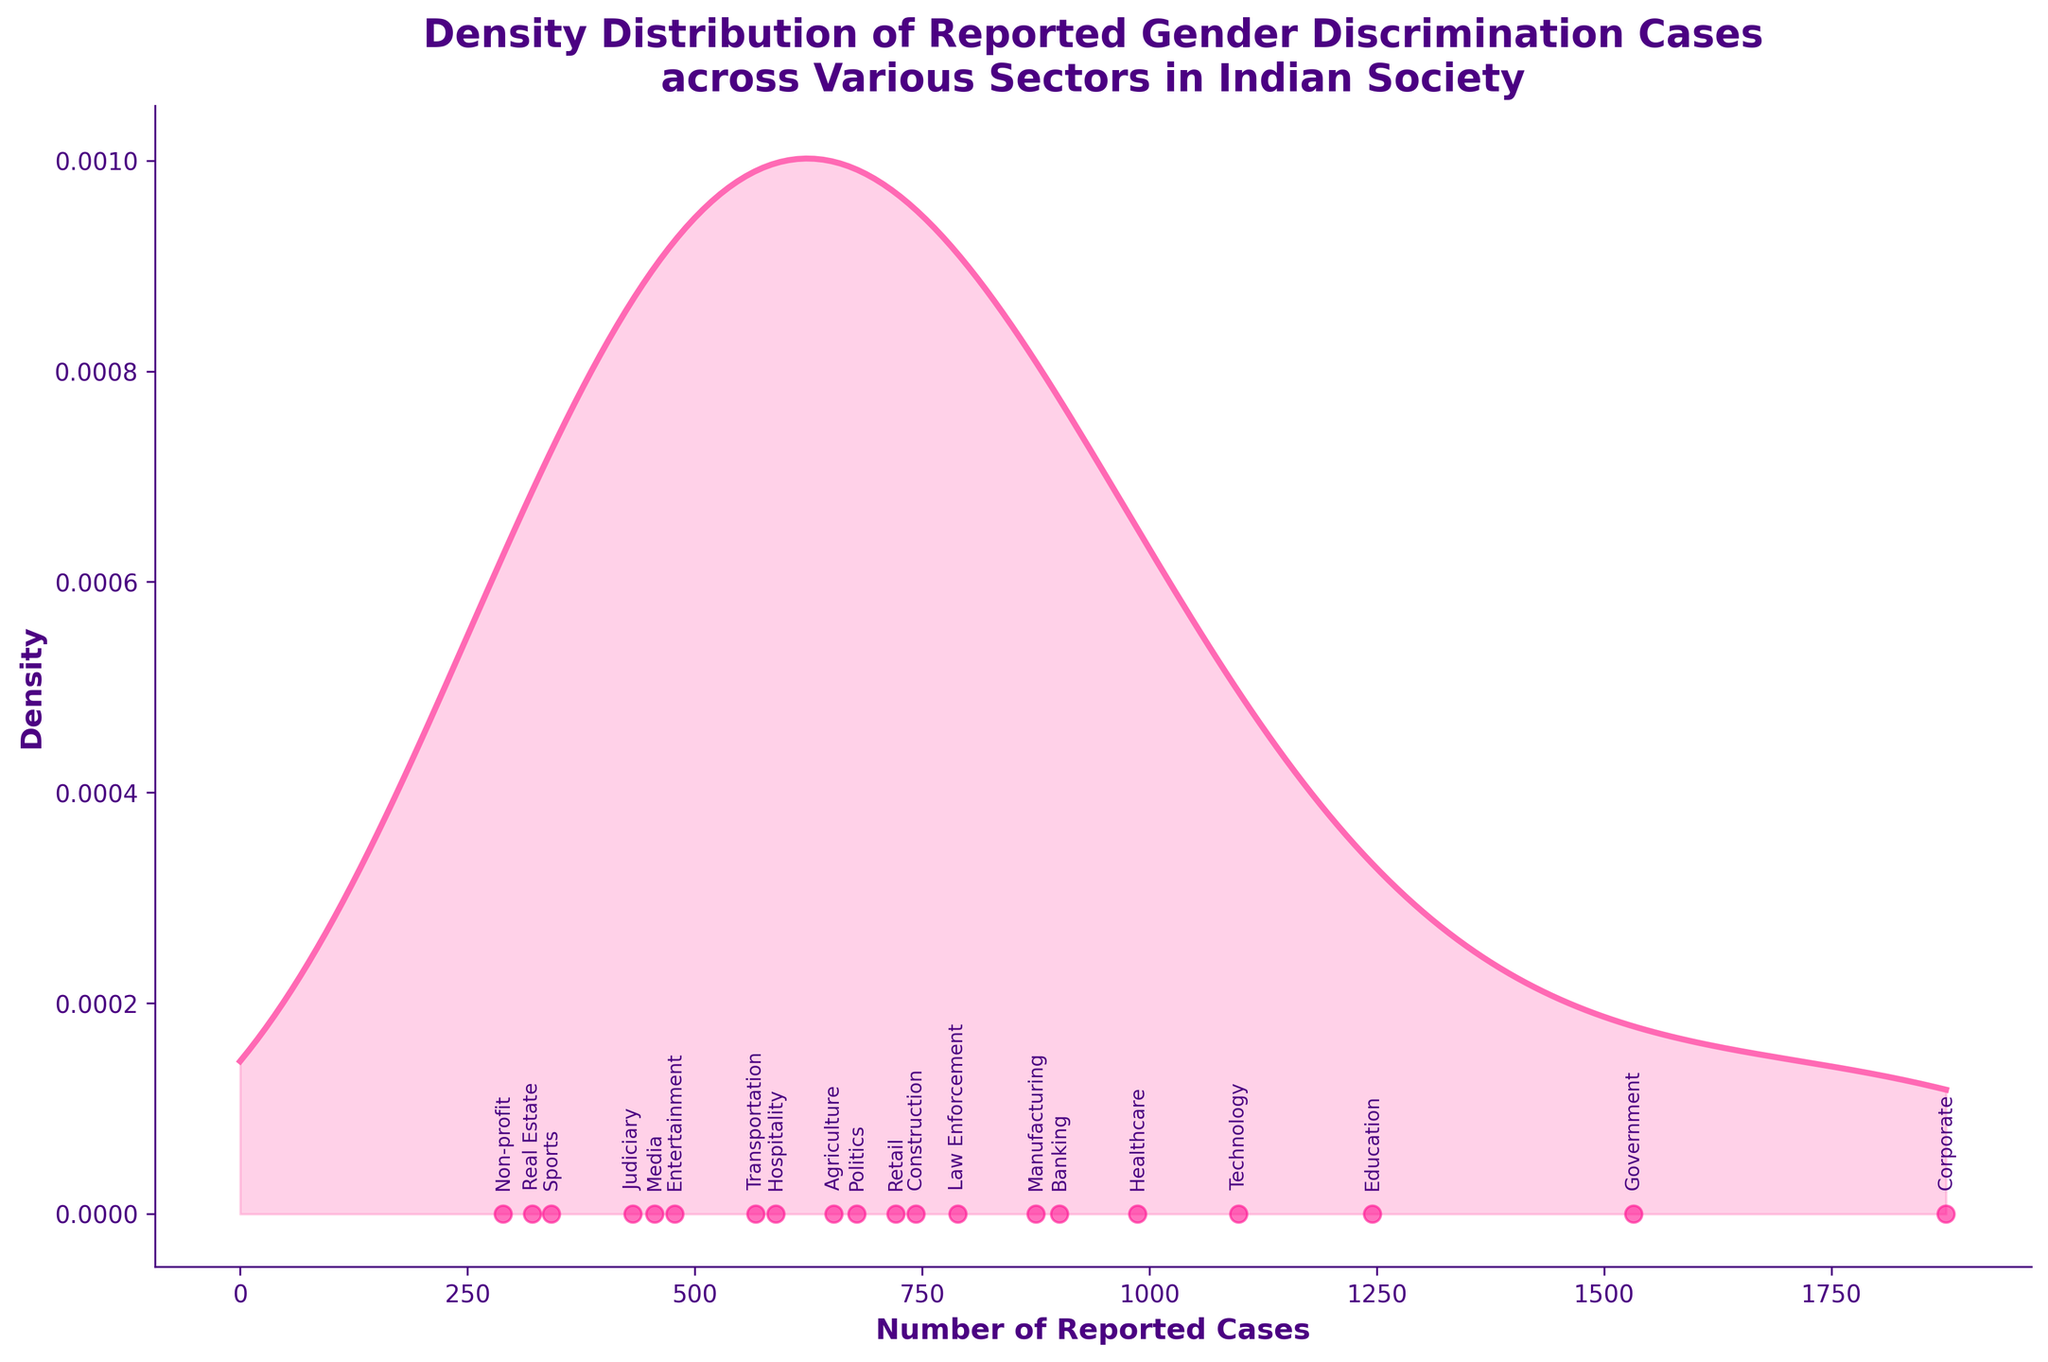How many sectors are represented in the plot? By examining the plot, we can count the number of distinct points with labels that correspond to the different sectors. Each sector is represented by an annotated data point.
Answer: 20 What is the sector with the highest number of reported cases? Look at the horizontal axis and find the sector label with the highest value on the x-axis. 'Corporate' has the highest number of reported cases at 1876.
Answer: Corporate Which sectors have fewer than 500 reported cases? Check the data points along the x-axis and find the sector labels corresponding to values less than 500. These sectors are 'Media', 'Sports', 'Judiciary', 'Real Estate', and 'Non-profit.'
Answer: Media, Sports, Judiciary, Real Estate, Non-profit What is the title of the plot? The title is clearly written at the top of the plot. It states, 'Density Distribution of Reported Gender Discrimination Cases across Various Sectors in Indian Society.'
Answer: Density Distribution of Reported Gender Discrimination Cases across Various Sectors in Indian Society How are the density and data points indicated on the plot? The density plot is indicated by the smooth curve filled with color, and the individual data points are shown as scattered points along the x-axis. The density curve is pink with a filled area and the data points are pink dots.
Answer: Density is shown by a pink curve with a filled area; data points are pink dots Which sector has reported cases closest to the median of all reported cases? To find the median, we need to order the cases from smallest to largest and determine the middle value. With 20 sectors, the median is the average of the 10th and 11th values when sorted. Sorting the cases, the median value is approximately 743. The sector 'Construction' has 743 reported cases.
Answer: Construction Is there a sector with exactly 1000 reported cases? By examining the x-axis values and corresponding sector annotations, there is no label positioned exactly at 1000 reported cases.
Answer: No Compare the number of reported cases in the Education and Healthcare sectors. Locate both 'Education' and 'Healthcare' on the plot and compare their x-axis values. Education has 1245 cases, while Healthcare has 987 cases. Education has more reported cases than Healthcare.
Answer: Education has more cases What is the range of reported cases across all sectors? To find the range, subtract the minimum number of reported cases from the maximum number. The maximum is 1876 and the minimum is 289. Range = 1876 - 289 = 1587.
Answer: 1587 Between which two consecutive sectors is the largest difference in the number of reported cases? Calculate the differences between each pair of consecutive sectors when sorted by number of cases. The largest difference is between Corporate (1876) and Government (1532), which is 1876 - 1532 = 344.
Answer: Corporate and Government 